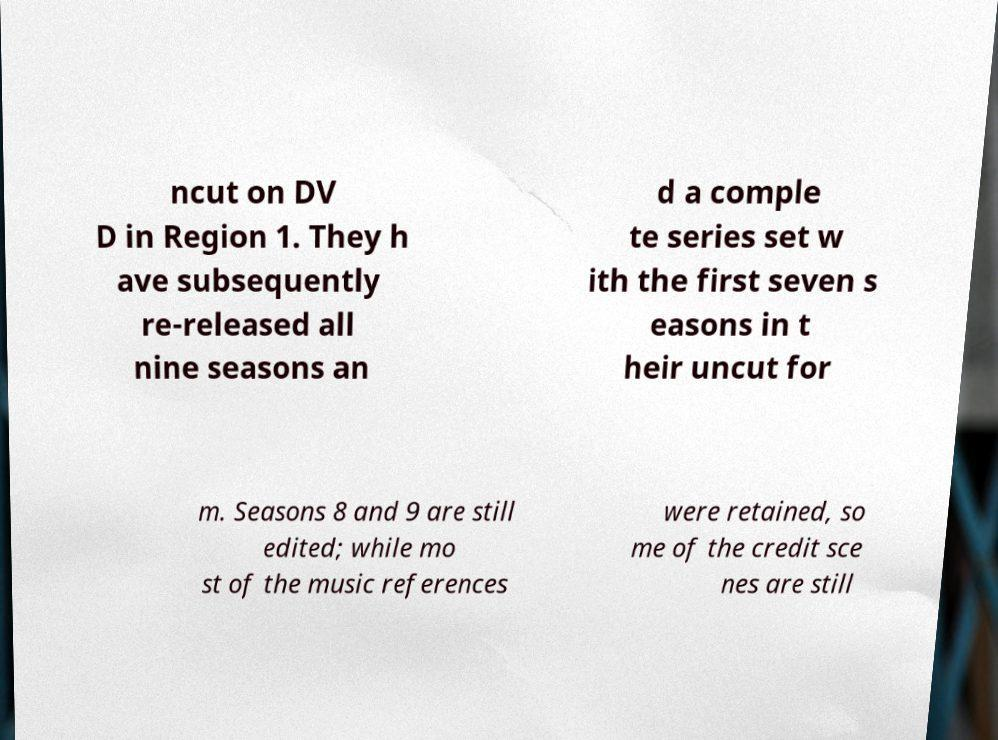Can you read and provide the text displayed in the image?This photo seems to have some interesting text. Can you extract and type it out for me? ncut on DV D in Region 1. They h ave subsequently re-released all nine seasons an d a comple te series set w ith the first seven s easons in t heir uncut for m. Seasons 8 and 9 are still edited; while mo st of the music references were retained, so me of the credit sce nes are still 